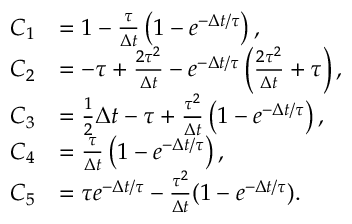<formula> <loc_0><loc_0><loc_500><loc_500>\begin{array} { r l } { C _ { 1 } } & { = 1 - \frac { \tau } { \Delta t } \left ( 1 - e ^ { - \Delta t / \tau } \right ) , } \\ { C _ { 2 } } & { = - \tau + \frac { 2 \tau ^ { 2 } } { \Delta t } - e ^ { - \Delta t / \tau } \left ( \frac { 2 \tau ^ { 2 } } { \Delta t } + \tau \right ) , } \\ { C _ { 3 } } & { = \frac { 1 } { 2 } \Delta t - \tau + \frac { \tau ^ { 2 } } { \Delta t } \left ( 1 - e ^ { - \Delta t / \tau } \right ) , } \\ { C _ { 4 } } & { = \frac { \tau } { \Delta t } \left ( 1 - e ^ { - \Delta t / \tau } \right ) , } \\ { C _ { 5 } } & { = \tau e ^ { - \Delta t / \tau } - \frac { \tau ^ { 2 } } { \Delta t } ( 1 - e ^ { - \Delta t / \tau } ) . } \end{array}</formula> 